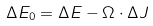Convert formula to latex. <formula><loc_0><loc_0><loc_500><loc_500>\Delta E _ { 0 } = \Delta E - { \Omega } \cdot \Delta { J }</formula> 